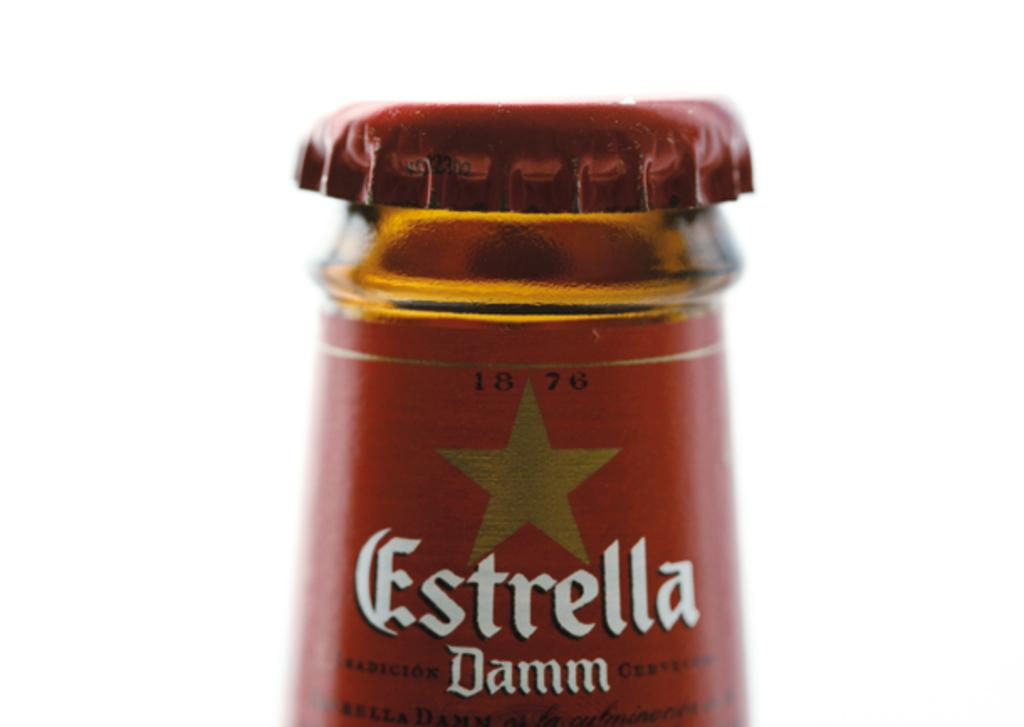<image>
Provide a brief description of the given image. the top of a 1876 bottle of estrella damm 